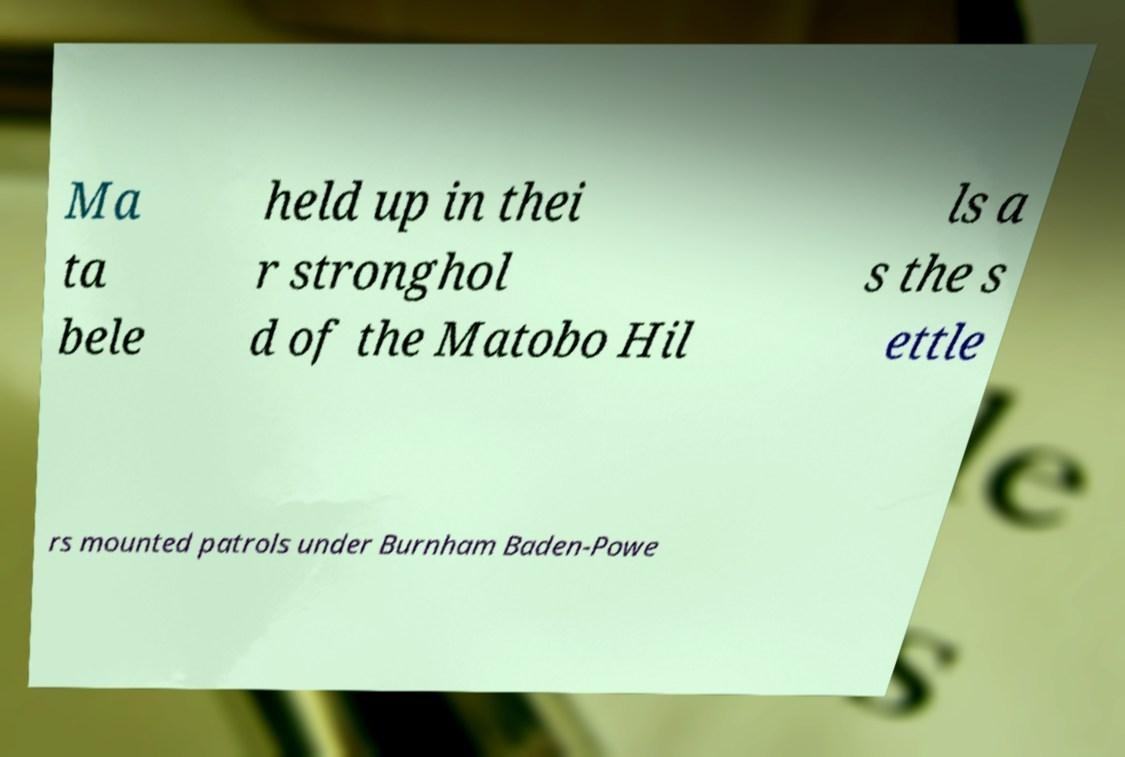For documentation purposes, I need the text within this image transcribed. Could you provide that? Ma ta bele held up in thei r stronghol d of the Matobo Hil ls a s the s ettle rs mounted patrols under Burnham Baden-Powe 